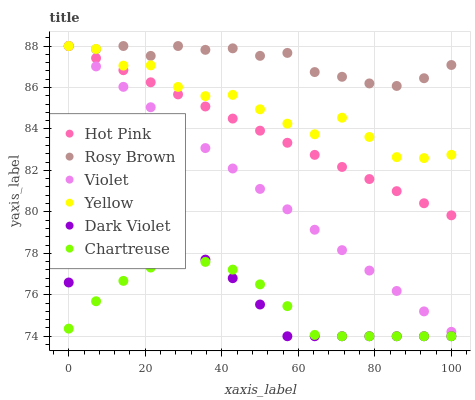Does Chartreuse have the minimum area under the curve?
Answer yes or no. Yes. Does Rosy Brown have the maximum area under the curve?
Answer yes or no. Yes. Does Dark Violet have the minimum area under the curve?
Answer yes or no. No. Does Dark Violet have the maximum area under the curve?
Answer yes or no. No. Is Hot Pink the smoothest?
Answer yes or no. Yes. Is Yellow the roughest?
Answer yes or no. Yes. Is Rosy Brown the smoothest?
Answer yes or no. No. Is Rosy Brown the roughest?
Answer yes or no. No. Does Dark Violet have the lowest value?
Answer yes or no. Yes. Does Rosy Brown have the lowest value?
Answer yes or no. No. Does Violet have the highest value?
Answer yes or no. Yes. Does Dark Violet have the highest value?
Answer yes or no. No. Is Dark Violet less than Hot Pink?
Answer yes or no. Yes. Is Rosy Brown greater than Chartreuse?
Answer yes or no. Yes. Does Yellow intersect Rosy Brown?
Answer yes or no. Yes. Is Yellow less than Rosy Brown?
Answer yes or no. No. Is Yellow greater than Rosy Brown?
Answer yes or no. No. Does Dark Violet intersect Hot Pink?
Answer yes or no. No. 